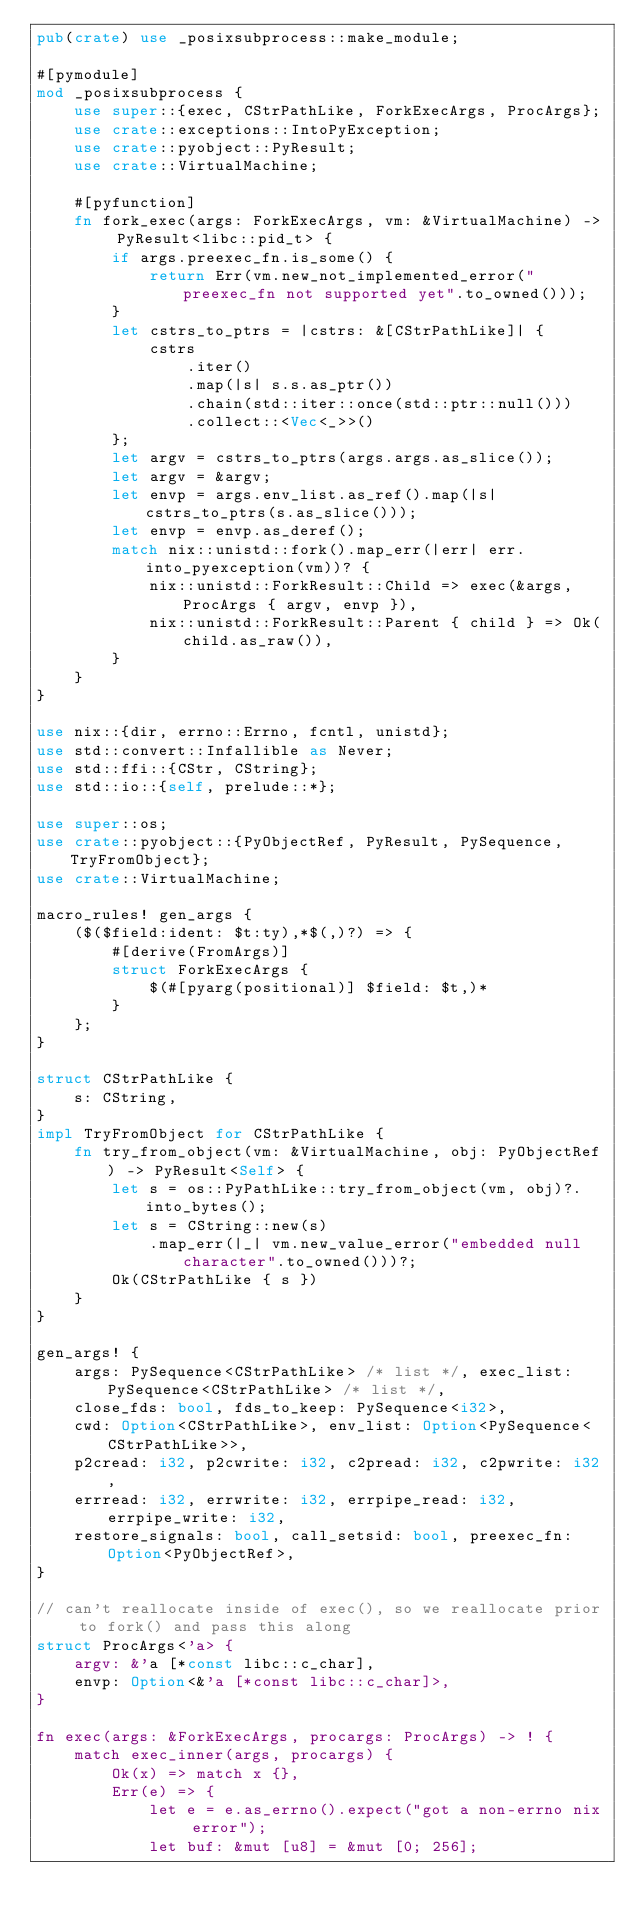<code> <loc_0><loc_0><loc_500><loc_500><_Rust_>pub(crate) use _posixsubprocess::make_module;

#[pymodule]
mod _posixsubprocess {
    use super::{exec, CStrPathLike, ForkExecArgs, ProcArgs};
    use crate::exceptions::IntoPyException;
    use crate::pyobject::PyResult;
    use crate::VirtualMachine;

    #[pyfunction]
    fn fork_exec(args: ForkExecArgs, vm: &VirtualMachine) -> PyResult<libc::pid_t> {
        if args.preexec_fn.is_some() {
            return Err(vm.new_not_implemented_error("preexec_fn not supported yet".to_owned()));
        }
        let cstrs_to_ptrs = |cstrs: &[CStrPathLike]| {
            cstrs
                .iter()
                .map(|s| s.s.as_ptr())
                .chain(std::iter::once(std::ptr::null()))
                .collect::<Vec<_>>()
        };
        let argv = cstrs_to_ptrs(args.args.as_slice());
        let argv = &argv;
        let envp = args.env_list.as_ref().map(|s| cstrs_to_ptrs(s.as_slice()));
        let envp = envp.as_deref();
        match nix::unistd::fork().map_err(|err| err.into_pyexception(vm))? {
            nix::unistd::ForkResult::Child => exec(&args, ProcArgs { argv, envp }),
            nix::unistd::ForkResult::Parent { child } => Ok(child.as_raw()),
        }
    }
}

use nix::{dir, errno::Errno, fcntl, unistd};
use std::convert::Infallible as Never;
use std::ffi::{CStr, CString};
use std::io::{self, prelude::*};

use super::os;
use crate::pyobject::{PyObjectRef, PyResult, PySequence, TryFromObject};
use crate::VirtualMachine;

macro_rules! gen_args {
    ($($field:ident: $t:ty),*$(,)?) => {
        #[derive(FromArgs)]
        struct ForkExecArgs {
            $(#[pyarg(positional)] $field: $t,)*
        }
    };
}

struct CStrPathLike {
    s: CString,
}
impl TryFromObject for CStrPathLike {
    fn try_from_object(vm: &VirtualMachine, obj: PyObjectRef) -> PyResult<Self> {
        let s = os::PyPathLike::try_from_object(vm, obj)?.into_bytes();
        let s = CString::new(s)
            .map_err(|_| vm.new_value_error("embedded null character".to_owned()))?;
        Ok(CStrPathLike { s })
    }
}

gen_args! {
    args: PySequence<CStrPathLike> /* list */, exec_list: PySequence<CStrPathLike> /* list */,
    close_fds: bool, fds_to_keep: PySequence<i32>,
    cwd: Option<CStrPathLike>, env_list: Option<PySequence<CStrPathLike>>,
    p2cread: i32, p2cwrite: i32, c2pread: i32, c2pwrite: i32,
    errread: i32, errwrite: i32, errpipe_read: i32, errpipe_write: i32,
    restore_signals: bool, call_setsid: bool, preexec_fn: Option<PyObjectRef>,
}

// can't reallocate inside of exec(), so we reallocate prior to fork() and pass this along
struct ProcArgs<'a> {
    argv: &'a [*const libc::c_char],
    envp: Option<&'a [*const libc::c_char]>,
}

fn exec(args: &ForkExecArgs, procargs: ProcArgs) -> ! {
    match exec_inner(args, procargs) {
        Ok(x) => match x {},
        Err(e) => {
            let e = e.as_errno().expect("got a non-errno nix error");
            let buf: &mut [u8] = &mut [0; 256];</code> 